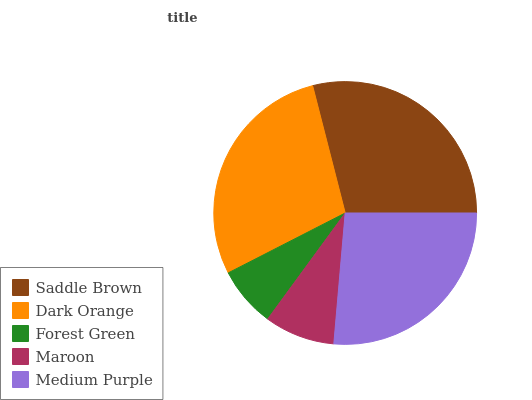Is Forest Green the minimum?
Answer yes or no. Yes. Is Saddle Brown the maximum?
Answer yes or no. Yes. Is Dark Orange the minimum?
Answer yes or no. No. Is Dark Orange the maximum?
Answer yes or no. No. Is Saddle Brown greater than Dark Orange?
Answer yes or no. Yes. Is Dark Orange less than Saddle Brown?
Answer yes or no. Yes. Is Dark Orange greater than Saddle Brown?
Answer yes or no. No. Is Saddle Brown less than Dark Orange?
Answer yes or no. No. Is Medium Purple the high median?
Answer yes or no. Yes. Is Medium Purple the low median?
Answer yes or no. Yes. Is Forest Green the high median?
Answer yes or no. No. Is Dark Orange the low median?
Answer yes or no. No. 